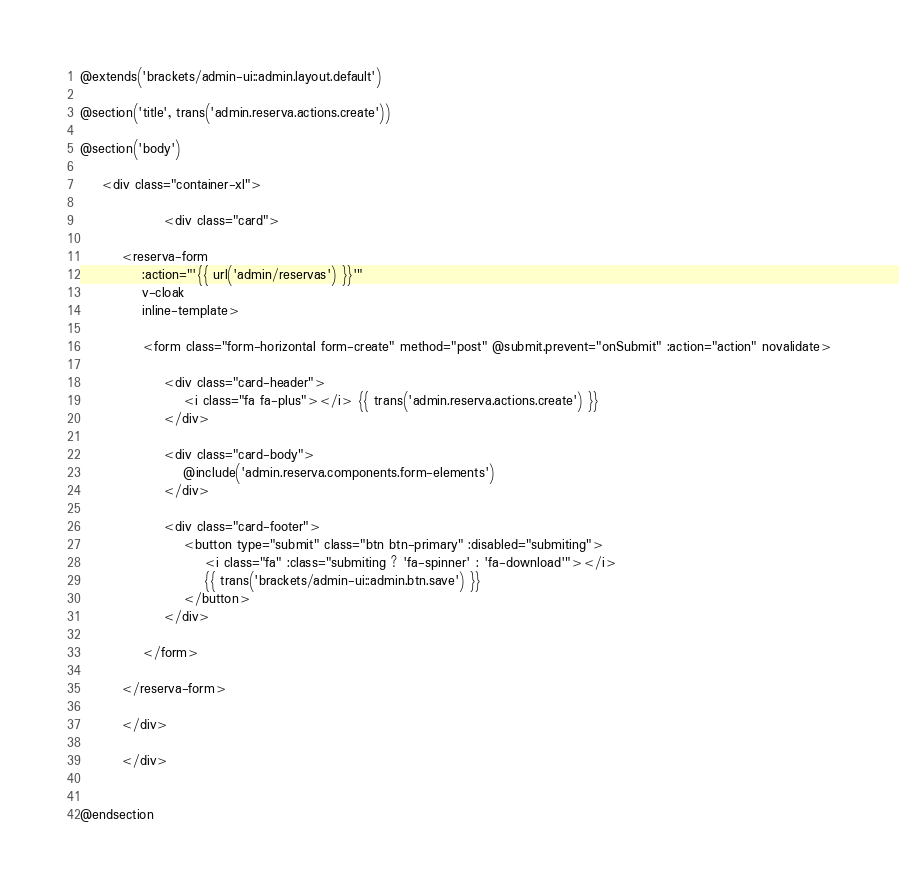<code> <loc_0><loc_0><loc_500><loc_500><_PHP_>@extends('brackets/admin-ui::admin.layout.default')

@section('title', trans('admin.reserva.actions.create'))

@section('body')

    <div class="container-xl">

                <div class="card">
        
        <reserva-form
            :action="'{{ url('admin/reservas') }}'"
            v-cloak
            inline-template>

            <form class="form-horizontal form-create" method="post" @submit.prevent="onSubmit" :action="action" novalidate>
                
                <div class="card-header">
                    <i class="fa fa-plus"></i> {{ trans('admin.reserva.actions.create') }}
                </div>

                <div class="card-body">
                    @include('admin.reserva.components.form-elements')
                </div>
                                
                <div class="card-footer">
                    <button type="submit" class="btn btn-primary" :disabled="submiting">
                        <i class="fa" :class="submiting ? 'fa-spinner' : 'fa-download'"></i>
                        {{ trans('brackets/admin-ui::admin.btn.save') }}
                    </button>
                </div>
                
            </form>

        </reserva-form>

        </div>

        </div>

    
@endsection</code> 